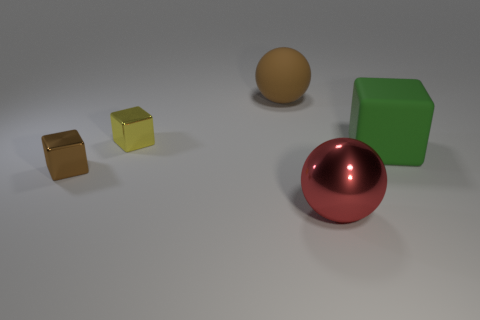Add 2 big green rubber objects. How many objects exist? 7 Subtract all large green matte cubes. How many cubes are left? 2 Subtract all spheres. How many objects are left? 3 Subtract all brown spheres. How many spheres are left? 1 Subtract 0 cyan balls. How many objects are left? 5 Subtract 1 cubes. How many cubes are left? 2 Subtract all red spheres. Subtract all purple cylinders. How many spheres are left? 1 Subtract all cyan spheres. How many brown blocks are left? 1 Subtract all metal blocks. Subtract all green metal things. How many objects are left? 3 Add 3 small yellow metal things. How many small yellow metal things are left? 4 